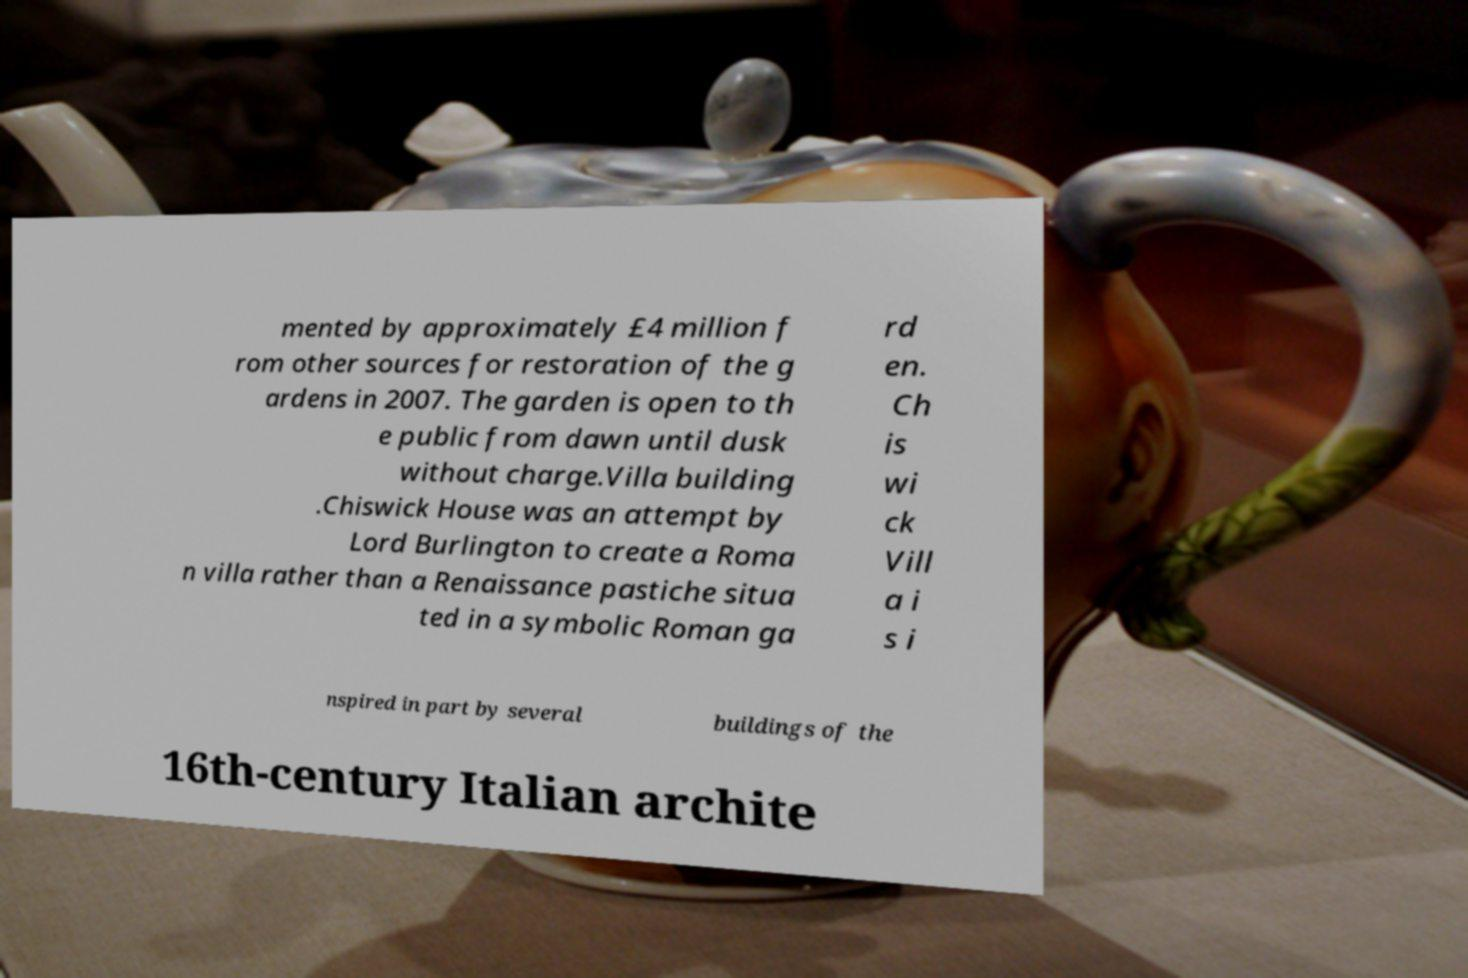What messages or text are displayed in this image? I need them in a readable, typed format. mented by approximately £4 million f rom other sources for restoration of the g ardens in 2007. The garden is open to th e public from dawn until dusk without charge.Villa building .Chiswick House was an attempt by Lord Burlington to create a Roma n villa rather than a Renaissance pastiche situa ted in a symbolic Roman ga rd en. Ch is wi ck Vill a i s i nspired in part by several buildings of the 16th-century Italian archite 